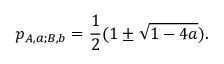Convert formula to latex. <formula><loc_0><loc_0><loc_500><loc_500>p _ { { A , a } ; { B , b } } = \frac { 1 } { 2 } ( 1 \pm \sqrt { 1 - 4 a } ) .</formula> 